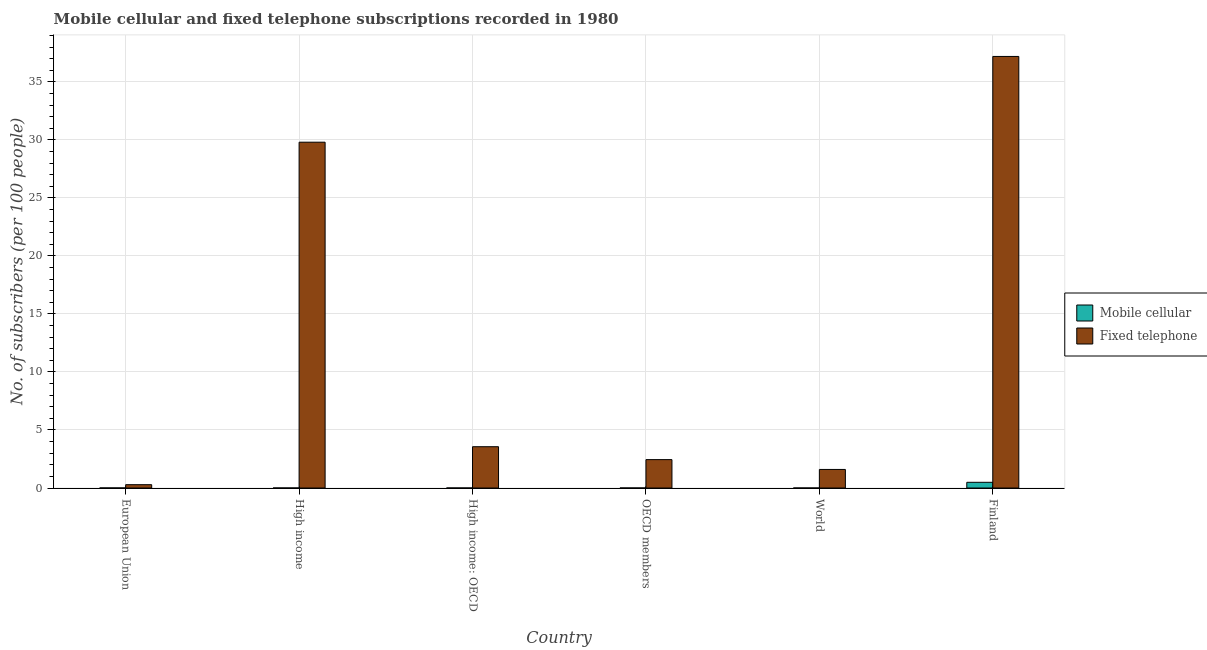How many groups of bars are there?
Give a very brief answer. 6. What is the label of the 3rd group of bars from the left?
Make the answer very short. High income: OECD. What is the number of mobile cellular subscribers in World?
Your answer should be compact. 0. Across all countries, what is the maximum number of mobile cellular subscribers?
Your response must be concise. 0.49. Across all countries, what is the minimum number of fixed telephone subscribers?
Your answer should be compact. 0.29. In which country was the number of mobile cellular subscribers maximum?
Make the answer very short. Finland. What is the total number of mobile cellular subscribers in the graph?
Offer a very short reply. 0.5. What is the difference between the number of mobile cellular subscribers in OECD members and that in World?
Provide a short and direct response. 0. What is the difference between the number of fixed telephone subscribers in OECD members and the number of mobile cellular subscribers in Finland?
Your answer should be very brief. 1.95. What is the average number of mobile cellular subscribers per country?
Give a very brief answer. 0.08. What is the difference between the number of mobile cellular subscribers and number of fixed telephone subscribers in High income: OECD?
Your answer should be very brief. -3.56. In how many countries, is the number of fixed telephone subscribers greater than 26 ?
Offer a very short reply. 2. What is the ratio of the number of mobile cellular subscribers in Finland to that in OECD members?
Keep it short and to the point. 205.67. Is the number of mobile cellular subscribers in High income less than that in High income: OECD?
Ensure brevity in your answer.  Yes. Is the difference between the number of fixed telephone subscribers in European Union and OECD members greater than the difference between the number of mobile cellular subscribers in European Union and OECD members?
Make the answer very short. No. What is the difference between the highest and the second highest number of fixed telephone subscribers?
Make the answer very short. 7.39. What is the difference between the highest and the lowest number of mobile cellular subscribers?
Offer a very short reply. 0.49. In how many countries, is the number of mobile cellular subscribers greater than the average number of mobile cellular subscribers taken over all countries?
Give a very brief answer. 1. Is the sum of the number of mobile cellular subscribers in European Union and High income greater than the maximum number of fixed telephone subscribers across all countries?
Provide a succinct answer. No. What does the 2nd bar from the left in OECD members represents?
Keep it short and to the point. Fixed telephone. What does the 1st bar from the right in Finland represents?
Your answer should be compact. Fixed telephone. Are all the bars in the graph horizontal?
Offer a very short reply. No. How many countries are there in the graph?
Provide a short and direct response. 6. Are the values on the major ticks of Y-axis written in scientific E-notation?
Make the answer very short. No. Does the graph contain grids?
Offer a very short reply. Yes. Where does the legend appear in the graph?
Your answer should be compact. Center right. What is the title of the graph?
Provide a succinct answer. Mobile cellular and fixed telephone subscriptions recorded in 1980. What is the label or title of the X-axis?
Offer a terse response. Country. What is the label or title of the Y-axis?
Your answer should be very brief. No. of subscribers (per 100 people). What is the No. of subscribers (per 100 people) of Mobile cellular in European Union?
Ensure brevity in your answer.  0.01. What is the No. of subscribers (per 100 people) of Fixed telephone in European Union?
Make the answer very short. 0.29. What is the No. of subscribers (per 100 people) in Mobile cellular in High income?
Ensure brevity in your answer.  0. What is the No. of subscribers (per 100 people) of Fixed telephone in High income?
Ensure brevity in your answer.  29.8. What is the No. of subscribers (per 100 people) in Mobile cellular in High income: OECD?
Offer a very short reply. 0. What is the No. of subscribers (per 100 people) in Fixed telephone in High income: OECD?
Provide a short and direct response. 3.56. What is the No. of subscribers (per 100 people) in Mobile cellular in OECD members?
Your response must be concise. 0. What is the No. of subscribers (per 100 people) in Fixed telephone in OECD members?
Your response must be concise. 2.45. What is the No. of subscribers (per 100 people) of Mobile cellular in World?
Provide a short and direct response. 0. What is the No. of subscribers (per 100 people) of Fixed telephone in World?
Keep it short and to the point. 1.6. What is the No. of subscribers (per 100 people) of Mobile cellular in Finland?
Provide a short and direct response. 0.49. What is the No. of subscribers (per 100 people) of Fixed telephone in Finland?
Your answer should be very brief. 37.19. Across all countries, what is the maximum No. of subscribers (per 100 people) in Mobile cellular?
Ensure brevity in your answer.  0.49. Across all countries, what is the maximum No. of subscribers (per 100 people) in Fixed telephone?
Provide a short and direct response. 37.19. Across all countries, what is the minimum No. of subscribers (per 100 people) in Mobile cellular?
Provide a short and direct response. 0. Across all countries, what is the minimum No. of subscribers (per 100 people) in Fixed telephone?
Offer a very short reply. 0.29. What is the total No. of subscribers (per 100 people) of Mobile cellular in the graph?
Keep it short and to the point. 0.5. What is the total No. of subscribers (per 100 people) of Fixed telephone in the graph?
Keep it short and to the point. 74.88. What is the difference between the No. of subscribers (per 100 people) of Mobile cellular in European Union and that in High income?
Ensure brevity in your answer.  0. What is the difference between the No. of subscribers (per 100 people) in Fixed telephone in European Union and that in High income?
Ensure brevity in your answer.  -29.51. What is the difference between the No. of subscribers (per 100 people) in Mobile cellular in European Union and that in High income: OECD?
Your answer should be very brief. 0. What is the difference between the No. of subscribers (per 100 people) of Fixed telephone in European Union and that in High income: OECD?
Offer a very short reply. -3.27. What is the difference between the No. of subscribers (per 100 people) of Mobile cellular in European Union and that in OECD members?
Provide a succinct answer. 0. What is the difference between the No. of subscribers (per 100 people) in Fixed telephone in European Union and that in OECD members?
Offer a very short reply. -2.16. What is the difference between the No. of subscribers (per 100 people) in Mobile cellular in European Union and that in World?
Provide a short and direct response. 0. What is the difference between the No. of subscribers (per 100 people) in Fixed telephone in European Union and that in World?
Your answer should be very brief. -1.31. What is the difference between the No. of subscribers (per 100 people) of Mobile cellular in European Union and that in Finland?
Provide a succinct answer. -0.49. What is the difference between the No. of subscribers (per 100 people) of Fixed telephone in European Union and that in Finland?
Ensure brevity in your answer.  -36.9. What is the difference between the No. of subscribers (per 100 people) in Mobile cellular in High income and that in High income: OECD?
Provide a short and direct response. -0. What is the difference between the No. of subscribers (per 100 people) of Fixed telephone in High income and that in High income: OECD?
Your answer should be compact. 26.24. What is the difference between the No. of subscribers (per 100 people) in Mobile cellular in High income and that in OECD members?
Ensure brevity in your answer.  -0. What is the difference between the No. of subscribers (per 100 people) of Fixed telephone in High income and that in OECD members?
Offer a terse response. 27.35. What is the difference between the No. of subscribers (per 100 people) in Mobile cellular in High income and that in World?
Offer a very short reply. 0. What is the difference between the No. of subscribers (per 100 people) in Fixed telephone in High income and that in World?
Provide a succinct answer. 28.2. What is the difference between the No. of subscribers (per 100 people) in Mobile cellular in High income and that in Finland?
Your response must be concise. -0.49. What is the difference between the No. of subscribers (per 100 people) in Fixed telephone in High income and that in Finland?
Ensure brevity in your answer.  -7.39. What is the difference between the No. of subscribers (per 100 people) in Fixed telephone in High income: OECD and that in OECD members?
Offer a terse response. 1.11. What is the difference between the No. of subscribers (per 100 people) of Mobile cellular in High income: OECD and that in World?
Your response must be concise. 0. What is the difference between the No. of subscribers (per 100 people) of Fixed telephone in High income: OECD and that in World?
Provide a succinct answer. 1.96. What is the difference between the No. of subscribers (per 100 people) of Mobile cellular in High income: OECD and that in Finland?
Provide a short and direct response. -0.49. What is the difference between the No. of subscribers (per 100 people) in Fixed telephone in High income: OECD and that in Finland?
Keep it short and to the point. -33.63. What is the difference between the No. of subscribers (per 100 people) in Mobile cellular in OECD members and that in World?
Your answer should be very brief. 0. What is the difference between the No. of subscribers (per 100 people) in Fixed telephone in OECD members and that in World?
Your response must be concise. 0.85. What is the difference between the No. of subscribers (per 100 people) in Mobile cellular in OECD members and that in Finland?
Give a very brief answer. -0.49. What is the difference between the No. of subscribers (per 100 people) in Fixed telephone in OECD members and that in Finland?
Your answer should be compact. -34.74. What is the difference between the No. of subscribers (per 100 people) in Mobile cellular in World and that in Finland?
Ensure brevity in your answer.  -0.49. What is the difference between the No. of subscribers (per 100 people) of Fixed telephone in World and that in Finland?
Offer a terse response. -35.59. What is the difference between the No. of subscribers (per 100 people) of Mobile cellular in European Union and the No. of subscribers (per 100 people) of Fixed telephone in High income?
Your answer should be very brief. -29.79. What is the difference between the No. of subscribers (per 100 people) of Mobile cellular in European Union and the No. of subscribers (per 100 people) of Fixed telephone in High income: OECD?
Provide a short and direct response. -3.55. What is the difference between the No. of subscribers (per 100 people) in Mobile cellular in European Union and the No. of subscribers (per 100 people) in Fixed telephone in OECD members?
Provide a succinct answer. -2.44. What is the difference between the No. of subscribers (per 100 people) in Mobile cellular in European Union and the No. of subscribers (per 100 people) in Fixed telephone in World?
Your answer should be very brief. -1.59. What is the difference between the No. of subscribers (per 100 people) in Mobile cellular in European Union and the No. of subscribers (per 100 people) in Fixed telephone in Finland?
Make the answer very short. -37.18. What is the difference between the No. of subscribers (per 100 people) in Mobile cellular in High income and the No. of subscribers (per 100 people) in Fixed telephone in High income: OECD?
Give a very brief answer. -3.56. What is the difference between the No. of subscribers (per 100 people) of Mobile cellular in High income and the No. of subscribers (per 100 people) of Fixed telephone in OECD members?
Offer a terse response. -2.44. What is the difference between the No. of subscribers (per 100 people) of Mobile cellular in High income and the No. of subscribers (per 100 people) of Fixed telephone in World?
Make the answer very short. -1.6. What is the difference between the No. of subscribers (per 100 people) in Mobile cellular in High income and the No. of subscribers (per 100 people) in Fixed telephone in Finland?
Make the answer very short. -37.19. What is the difference between the No. of subscribers (per 100 people) in Mobile cellular in High income: OECD and the No. of subscribers (per 100 people) in Fixed telephone in OECD members?
Your answer should be very brief. -2.44. What is the difference between the No. of subscribers (per 100 people) of Mobile cellular in High income: OECD and the No. of subscribers (per 100 people) of Fixed telephone in World?
Offer a very short reply. -1.6. What is the difference between the No. of subscribers (per 100 people) in Mobile cellular in High income: OECD and the No. of subscribers (per 100 people) in Fixed telephone in Finland?
Provide a short and direct response. -37.19. What is the difference between the No. of subscribers (per 100 people) in Mobile cellular in OECD members and the No. of subscribers (per 100 people) in Fixed telephone in World?
Keep it short and to the point. -1.6. What is the difference between the No. of subscribers (per 100 people) in Mobile cellular in OECD members and the No. of subscribers (per 100 people) in Fixed telephone in Finland?
Your answer should be compact. -37.19. What is the difference between the No. of subscribers (per 100 people) of Mobile cellular in World and the No. of subscribers (per 100 people) of Fixed telephone in Finland?
Offer a terse response. -37.19. What is the average No. of subscribers (per 100 people) of Mobile cellular per country?
Your response must be concise. 0.08. What is the average No. of subscribers (per 100 people) of Fixed telephone per country?
Offer a terse response. 12.48. What is the difference between the No. of subscribers (per 100 people) of Mobile cellular and No. of subscribers (per 100 people) of Fixed telephone in European Union?
Offer a very short reply. -0.28. What is the difference between the No. of subscribers (per 100 people) in Mobile cellular and No. of subscribers (per 100 people) in Fixed telephone in High income?
Provide a succinct answer. -29.8. What is the difference between the No. of subscribers (per 100 people) of Mobile cellular and No. of subscribers (per 100 people) of Fixed telephone in High income: OECD?
Your answer should be very brief. -3.56. What is the difference between the No. of subscribers (per 100 people) of Mobile cellular and No. of subscribers (per 100 people) of Fixed telephone in OECD members?
Offer a very short reply. -2.44. What is the difference between the No. of subscribers (per 100 people) in Mobile cellular and No. of subscribers (per 100 people) in Fixed telephone in World?
Provide a short and direct response. -1.6. What is the difference between the No. of subscribers (per 100 people) in Mobile cellular and No. of subscribers (per 100 people) in Fixed telephone in Finland?
Ensure brevity in your answer.  -36.7. What is the ratio of the No. of subscribers (per 100 people) of Mobile cellular in European Union to that in High income?
Your answer should be very brief. 2.37. What is the ratio of the No. of subscribers (per 100 people) in Fixed telephone in European Union to that in High income?
Give a very brief answer. 0.01. What is the ratio of the No. of subscribers (per 100 people) of Mobile cellular in European Union to that in High income: OECD?
Provide a short and direct response. 1.87. What is the ratio of the No. of subscribers (per 100 people) in Fixed telephone in European Union to that in High income: OECD?
Offer a terse response. 0.08. What is the ratio of the No. of subscribers (per 100 people) in Mobile cellular in European Union to that in OECD members?
Your response must be concise. 2.12. What is the ratio of the No. of subscribers (per 100 people) in Fixed telephone in European Union to that in OECD members?
Ensure brevity in your answer.  0.12. What is the ratio of the No. of subscribers (per 100 people) of Mobile cellular in European Union to that in World?
Offer a very short reply. 9.54. What is the ratio of the No. of subscribers (per 100 people) in Fixed telephone in European Union to that in World?
Provide a succinct answer. 0.18. What is the ratio of the No. of subscribers (per 100 people) of Mobile cellular in European Union to that in Finland?
Ensure brevity in your answer.  0.01. What is the ratio of the No. of subscribers (per 100 people) in Fixed telephone in European Union to that in Finland?
Your answer should be compact. 0.01. What is the ratio of the No. of subscribers (per 100 people) of Mobile cellular in High income to that in High income: OECD?
Make the answer very short. 0.79. What is the ratio of the No. of subscribers (per 100 people) in Fixed telephone in High income to that in High income: OECD?
Your answer should be very brief. 8.37. What is the ratio of the No. of subscribers (per 100 people) in Mobile cellular in High income to that in OECD members?
Keep it short and to the point. 0.89. What is the ratio of the No. of subscribers (per 100 people) of Fixed telephone in High income to that in OECD members?
Give a very brief answer. 12.18. What is the ratio of the No. of subscribers (per 100 people) of Mobile cellular in High income to that in World?
Keep it short and to the point. 4.02. What is the ratio of the No. of subscribers (per 100 people) in Fixed telephone in High income to that in World?
Offer a very short reply. 18.64. What is the ratio of the No. of subscribers (per 100 people) of Mobile cellular in High income to that in Finland?
Give a very brief answer. 0. What is the ratio of the No. of subscribers (per 100 people) in Fixed telephone in High income to that in Finland?
Offer a very short reply. 0.8. What is the ratio of the No. of subscribers (per 100 people) in Mobile cellular in High income: OECD to that in OECD members?
Give a very brief answer. 1.13. What is the ratio of the No. of subscribers (per 100 people) in Fixed telephone in High income: OECD to that in OECD members?
Your answer should be very brief. 1.46. What is the ratio of the No. of subscribers (per 100 people) of Mobile cellular in High income: OECD to that in World?
Provide a short and direct response. 5.09. What is the ratio of the No. of subscribers (per 100 people) in Fixed telephone in High income: OECD to that in World?
Provide a succinct answer. 2.23. What is the ratio of the No. of subscribers (per 100 people) of Mobile cellular in High income: OECD to that in Finland?
Give a very brief answer. 0.01. What is the ratio of the No. of subscribers (per 100 people) in Fixed telephone in High income: OECD to that in Finland?
Keep it short and to the point. 0.1. What is the ratio of the No. of subscribers (per 100 people) in Mobile cellular in OECD members to that in World?
Keep it short and to the point. 4.5. What is the ratio of the No. of subscribers (per 100 people) of Fixed telephone in OECD members to that in World?
Keep it short and to the point. 1.53. What is the ratio of the No. of subscribers (per 100 people) of Mobile cellular in OECD members to that in Finland?
Your answer should be very brief. 0. What is the ratio of the No. of subscribers (per 100 people) in Fixed telephone in OECD members to that in Finland?
Provide a short and direct response. 0.07. What is the ratio of the No. of subscribers (per 100 people) in Mobile cellular in World to that in Finland?
Give a very brief answer. 0. What is the ratio of the No. of subscribers (per 100 people) of Fixed telephone in World to that in Finland?
Your answer should be very brief. 0.04. What is the difference between the highest and the second highest No. of subscribers (per 100 people) in Mobile cellular?
Your answer should be very brief. 0.49. What is the difference between the highest and the second highest No. of subscribers (per 100 people) of Fixed telephone?
Make the answer very short. 7.39. What is the difference between the highest and the lowest No. of subscribers (per 100 people) in Mobile cellular?
Your answer should be very brief. 0.49. What is the difference between the highest and the lowest No. of subscribers (per 100 people) of Fixed telephone?
Your answer should be compact. 36.9. 